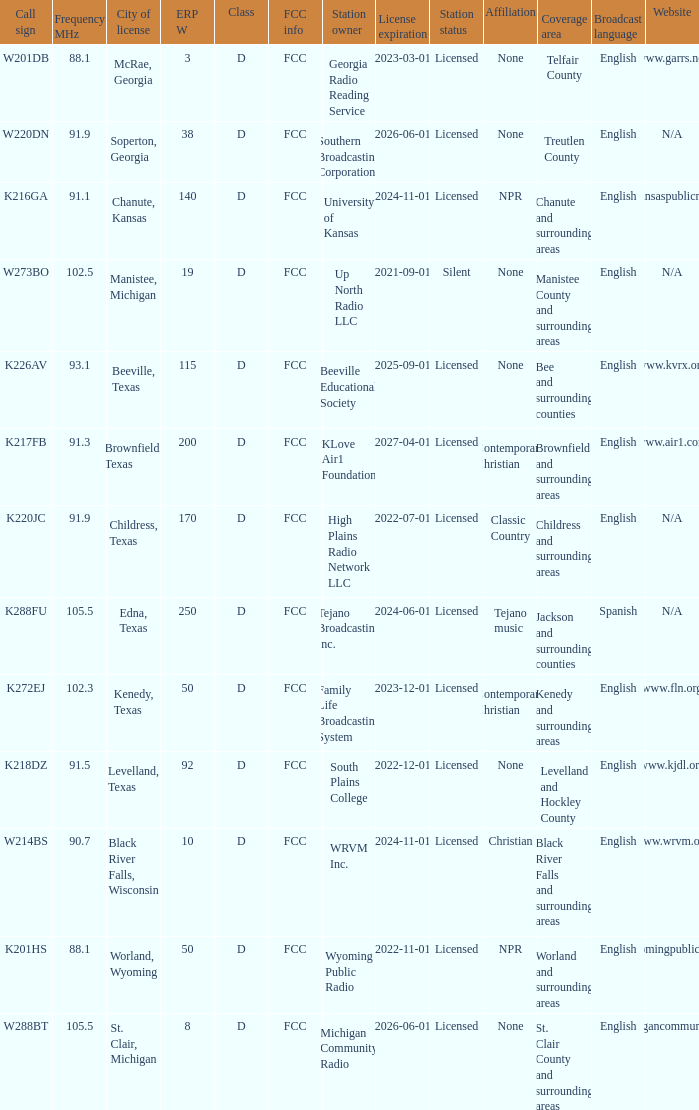What is Call Sign, when City of License is Brownfield, Texas? K217FB. 